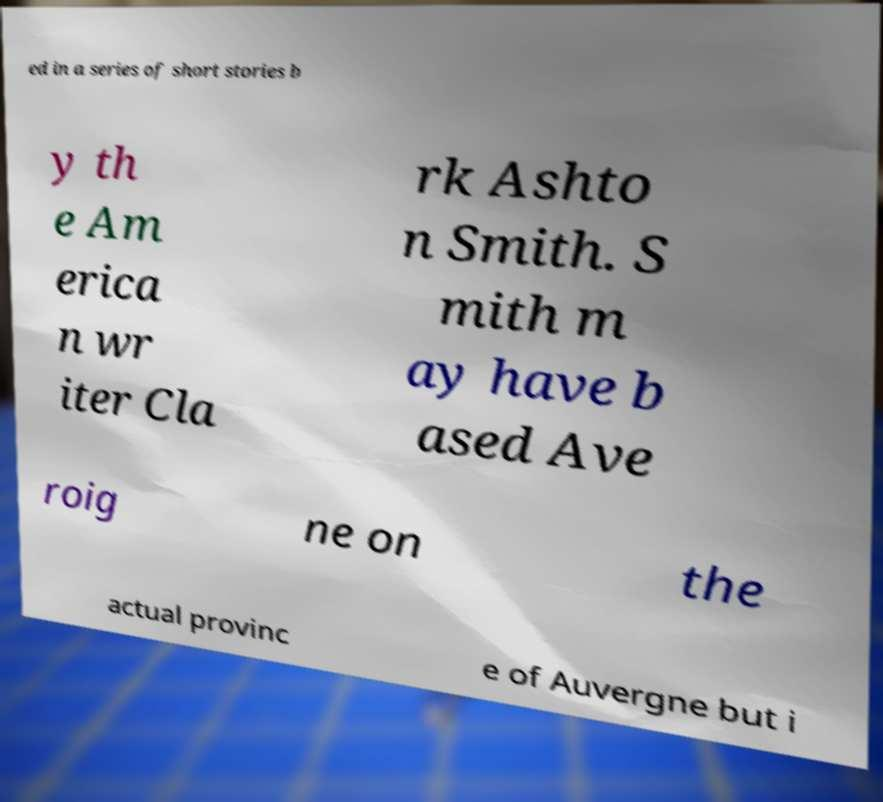What messages or text are displayed in this image? I need them in a readable, typed format. ed in a series of short stories b y th e Am erica n wr iter Cla rk Ashto n Smith. S mith m ay have b ased Ave roig ne on the actual provinc e of Auvergne but i 